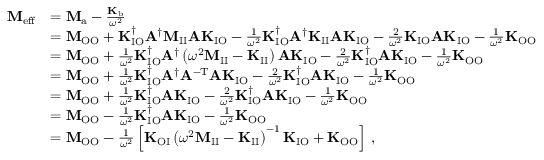Convert formula to latex. <formula><loc_0><loc_0><loc_500><loc_500>\begin{array} { r l } { M _ { e f f } } & { = M _ { a } - \frac { K _ { b } } { \omega ^ { 2 } } } \\ & { = M _ { O O } + K _ { I O } ^ { \dagger } A ^ { \dagger } M _ { I I } A K _ { I O } - \frac { 1 } { \omega ^ { 2 } } K _ { I O } ^ { \dagger } A ^ { \dagger } K _ { I I } A K _ { I O } - \frac { 2 } { \omega ^ { 2 } } K _ { I O } A K _ { I O } - \frac { 1 } { \omega ^ { 2 } } K _ { O O } \, } \\ & { = M _ { O O } + \frac { 1 } { \omega ^ { 2 } } K _ { I O } ^ { \dagger } A ^ { \dagger } \left ( \omega ^ { 2 } M _ { I I } - K _ { I I } \right ) A K _ { I O } - \frac { 2 } { \omega ^ { 2 } } K _ { I O } ^ { \dagger } A K _ { I O } - \frac { 1 } { \omega ^ { 2 } } K _ { O O } \, } \\ & { = M _ { O O } + \frac { 1 } { \omega ^ { 2 } } K _ { I O } ^ { \dagger } A ^ { \dagger } A ^ { - T } A K _ { I O } - \frac { 2 } { \omega ^ { 2 } } K _ { I O } ^ { \dagger } A K _ { I O } - \frac { 1 } { \omega ^ { 2 } } K _ { O O } } \\ & { = M _ { O O } + \frac { 1 } { \omega ^ { 2 } } K _ { I O } ^ { \dagger } A K _ { I O } - \frac { 2 } { \omega ^ { 2 } } K _ { I O } ^ { \dagger } A K _ { I O } - \frac { 1 } { \omega ^ { 2 } } K _ { O O } } \\ & { = M _ { O O } - \frac { 1 } { \omega ^ { 2 } } K _ { I O } ^ { \dagger } A K _ { I O } - \frac { 1 } { \omega ^ { 2 } } K _ { O O } } \\ & { = M _ { O O } - \frac { 1 } { \omega ^ { 2 } } \left [ K _ { O I } \left ( \omega ^ { 2 } M _ { I I } - K _ { I I } \right ) ^ { - 1 } K _ { I O } + K _ { O O } \right ] \, , } \end{array}</formula> 